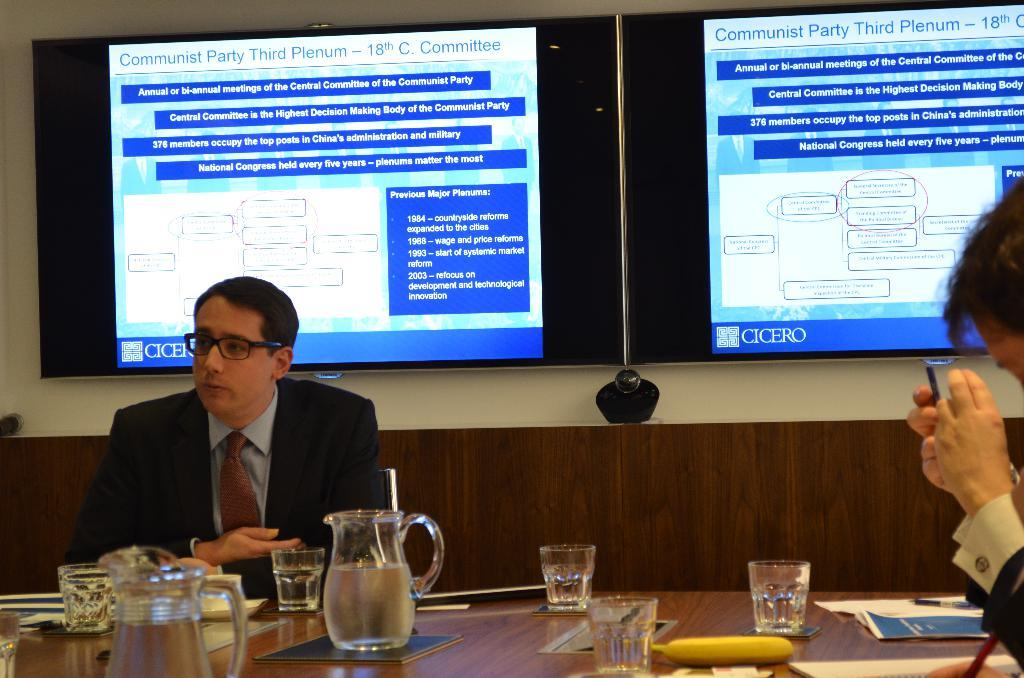<image>
Describe the image concisely. Two men sit around a conference table with two screens on the far wall referencing the "Communist Party Third Plenum - 18th C. Committee." 